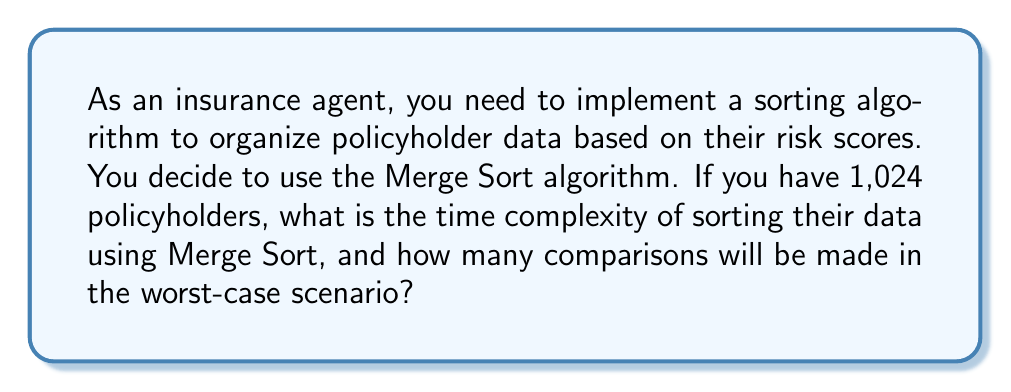Help me with this question. To solve this problem, we need to understand the properties of the Merge Sort algorithm and apply them to the given scenario.

1. Time Complexity of Merge Sort:
   Merge Sort has a time complexity of $O(n \log n)$ for all cases (best, average, and worst).

2. Number of Comparisons:
   For Merge Sort, the number of comparisons in the worst case can be calculated using the formula:
   $$C(n) = n \log_2 n - n + 1$$
   Where $n$ is the number of elements to be sorted.

3. Given Information:
   Number of policyholders, $n = 1,024$

4. Calculating the number of comparisons:
   $$\begin{align}
   C(1024) &= 1024 \log_2 1024 - 1024 + 1 \\
   &= 1024 \times 10 - 1024 + 1 \\
   &= 10240 - 1024 + 1 \\
   &= 9217
   \end{align}$$

Therefore, the time complexity of sorting 1,024 policyholders using Merge Sort is $O(n \log n)$, and the number of comparisons in the worst-case scenario is 9,217.
Answer: Time complexity: $O(n \log n)$
Number of comparisons: 9,217 